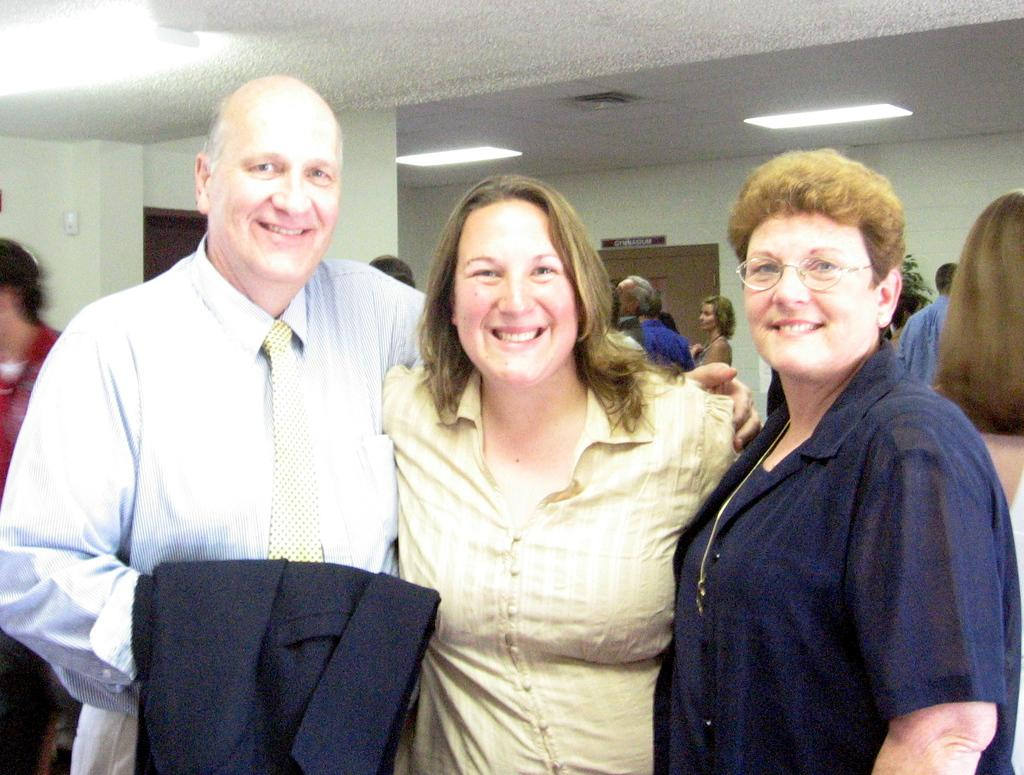How many people are in the image? There are three people in the image. What expressions do the people in the image have? The three people are smiling. What can be seen in the background of the image? There are people, a wall, a roof, and lights in the background of the image. What month is being celebrated in the image? There is no indication of a specific month being celebrated in the image. Is there a party happening in the image? There is no indication of a party or any specific event taking place in the image. 